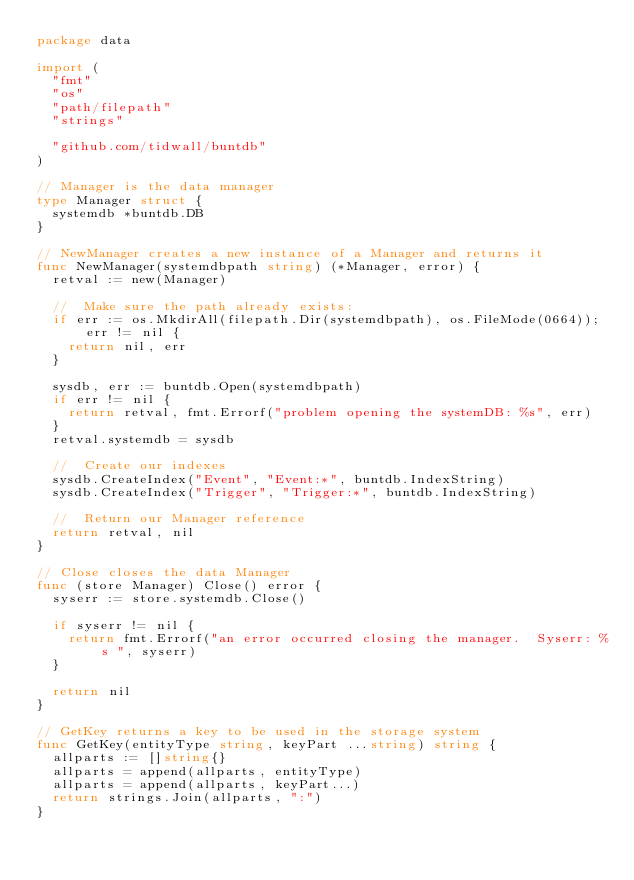Convert code to text. <code><loc_0><loc_0><loc_500><loc_500><_Go_>package data

import (
	"fmt"
	"os"
	"path/filepath"
	"strings"

	"github.com/tidwall/buntdb"
)

// Manager is the data manager
type Manager struct {
	systemdb *buntdb.DB
}

// NewManager creates a new instance of a Manager and returns it
func NewManager(systemdbpath string) (*Manager, error) {
	retval := new(Manager)

	//	Make sure the path already exists:
	if err := os.MkdirAll(filepath.Dir(systemdbpath), os.FileMode(0664)); err != nil {
		return nil, err
	}

	sysdb, err := buntdb.Open(systemdbpath)
	if err != nil {
		return retval, fmt.Errorf("problem opening the systemDB: %s", err)
	}
	retval.systemdb = sysdb

	//	Create our indexes
	sysdb.CreateIndex("Event", "Event:*", buntdb.IndexString)
	sysdb.CreateIndex("Trigger", "Trigger:*", buntdb.IndexString)

	//	Return our Manager reference
	return retval, nil
}

// Close closes the data Manager
func (store Manager) Close() error {
	syserr := store.systemdb.Close()

	if syserr != nil {
		return fmt.Errorf("an error occurred closing the manager.  Syserr: %s ", syserr)
	}

	return nil
}

// GetKey returns a key to be used in the storage system
func GetKey(entityType string, keyPart ...string) string {
	allparts := []string{}
	allparts = append(allparts, entityType)
	allparts = append(allparts, keyPart...)
	return strings.Join(allparts, ":")
}
</code> 